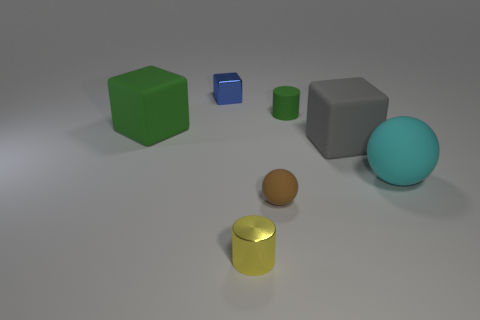Subtract all big gray blocks. How many blocks are left? 2 Subtract all gray cubes. How many cubes are left? 2 Add 3 tiny matte balls. How many objects exist? 10 Subtract 1 cubes. How many cubes are left? 2 Subtract all cyan spheres. Subtract all blue cylinders. How many spheres are left? 1 Subtract all blue spheres. How many green cylinders are left? 1 Subtract all small yellow cylinders. Subtract all brown balls. How many objects are left? 5 Add 6 tiny brown things. How many tiny brown things are left? 7 Add 7 yellow blocks. How many yellow blocks exist? 7 Subtract 0 cyan cylinders. How many objects are left? 7 